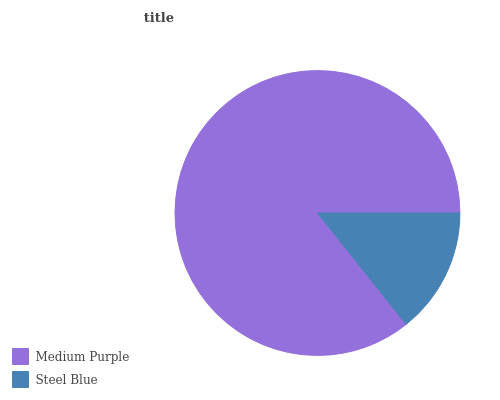Is Steel Blue the minimum?
Answer yes or no. Yes. Is Medium Purple the maximum?
Answer yes or no. Yes. Is Steel Blue the maximum?
Answer yes or no. No. Is Medium Purple greater than Steel Blue?
Answer yes or no. Yes. Is Steel Blue less than Medium Purple?
Answer yes or no. Yes. Is Steel Blue greater than Medium Purple?
Answer yes or no. No. Is Medium Purple less than Steel Blue?
Answer yes or no. No. Is Medium Purple the high median?
Answer yes or no. Yes. Is Steel Blue the low median?
Answer yes or no. Yes. Is Steel Blue the high median?
Answer yes or no. No. Is Medium Purple the low median?
Answer yes or no. No. 